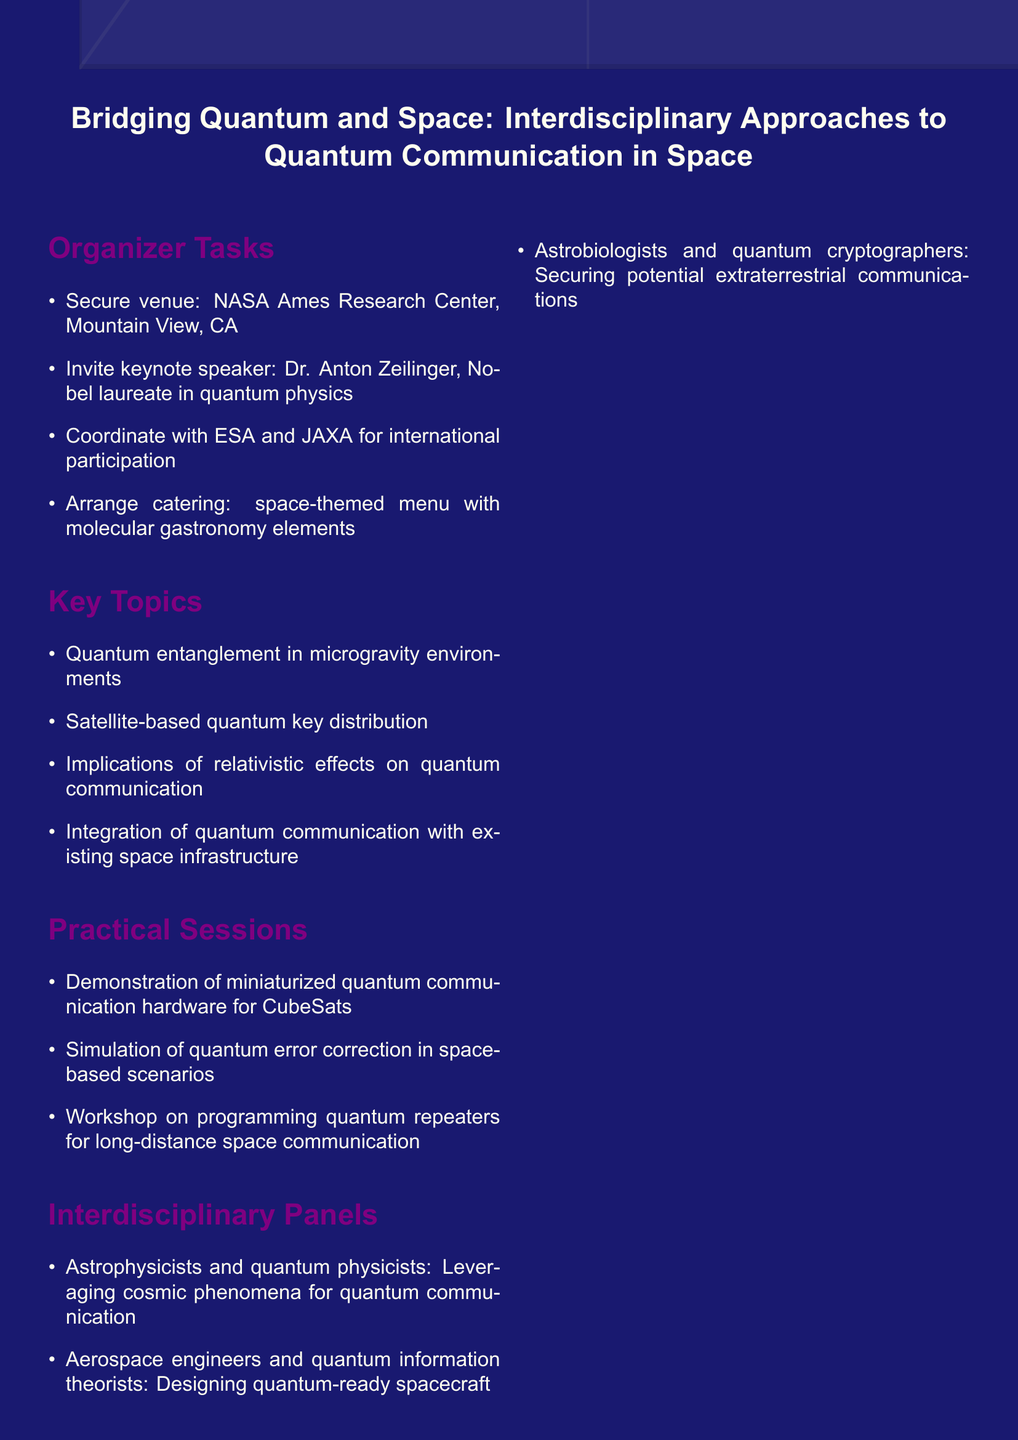What is the title of the workshop? The title is stated at the beginning of the document.
Answer: Bridging Quantum and Space: Interdisciplinary Approaches to Quantum Communication in Space Who is the keynote speaker? The keynote speaker is mentioned in the organizer tasks section.
Answer: Dr. Anton Zeilinger What is one of the key topics discussed in the workshop? The key topics are listed in a specific section of the document.
Answer: Quantum entanglement in microgravity environments Where is the venue for the workshop? The venue is specified under the organizer tasks section.
Answer: NASA Ames Research Center, Mountain View, CA What is one expected outcome of the workshop? Expected outcomes are detailed in a separate section of the document.
Answer: White paper on the roadmap for implementing quantum communication in space by 2030 Which organizations are coordinated with for participation? The organizations are listed in the organizer tasks section.
Answer: ESA and JAXA What type of practical session will be demonstrated? Practical sessions are described, focusing on specific activities.
Answer: Demonstration of miniaturized quantum communication hardware for CubeSats What is one follow-up action mentioned? Follow-up actions are documented in their own section.
Answer: Submit proposal to NASA's Advanced Innovative Concepts (NIAC) program What kind of menu is arranged for catering? The catering details are specified in the organizer tasks.
Answer: Space-themed menu with molecular gastronomy elements 